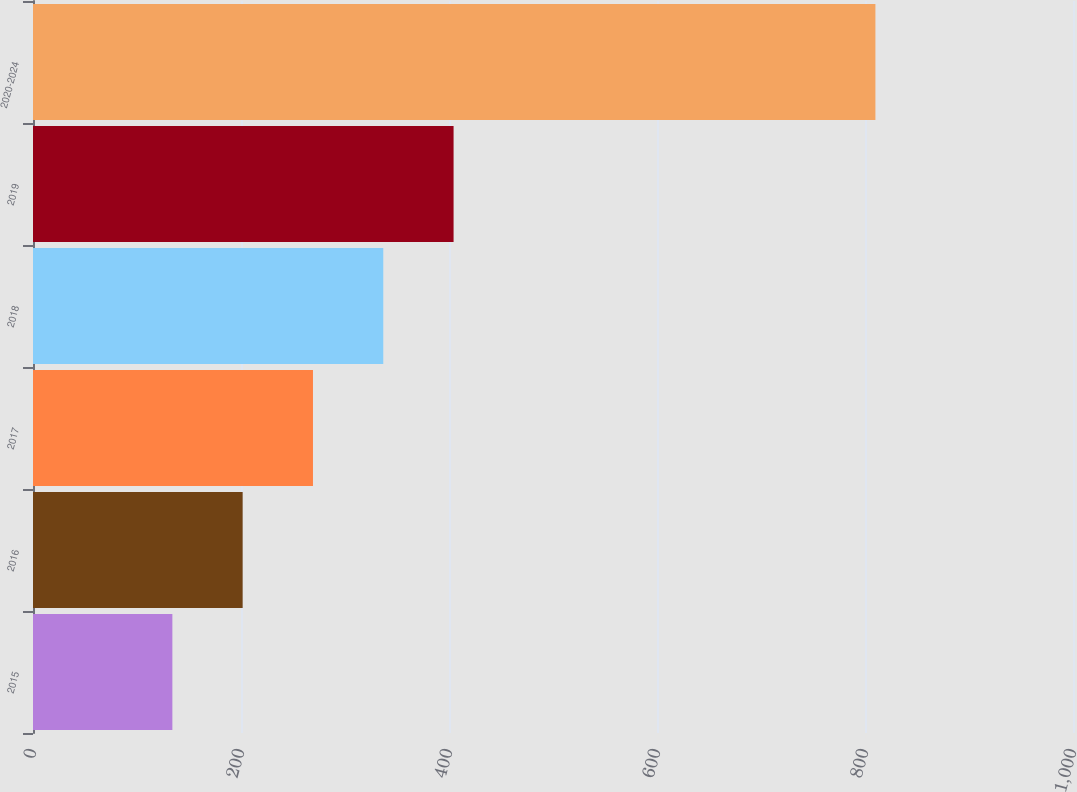Convert chart to OTSL. <chart><loc_0><loc_0><loc_500><loc_500><bar_chart><fcel>2015<fcel>2016<fcel>2017<fcel>2018<fcel>2019<fcel>2020-2024<nl><fcel>134<fcel>201.6<fcel>269.2<fcel>336.8<fcel>404.4<fcel>810<nl></chart> 